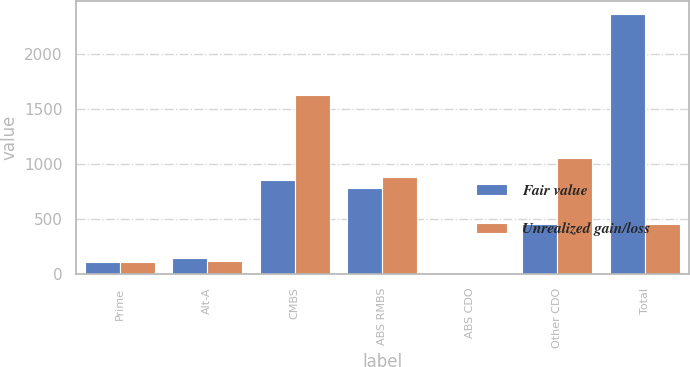Convert chart to OTSL. <chart><loc_0><loc_0><loc_500><loc_500><stacked_bar_chart><ecel><fcel>Prime<fcel>Alt-A<fcel>CMBS<fcel>ABS RMBS<fcel>ABS CDO<fcel>Other CDO<fcel>Total<nl><fcel>Fair value<fcel>113<fcel>146<fcel>858<fcel>781<fcel>4<fcel>459<fcel>2361<nl><fcel>Unrealized gain/loss<fcel>113<fcel>122<fcel>1625<fcel>878<fcel>3<fcel>1054<fcel>459<nl></chart> 